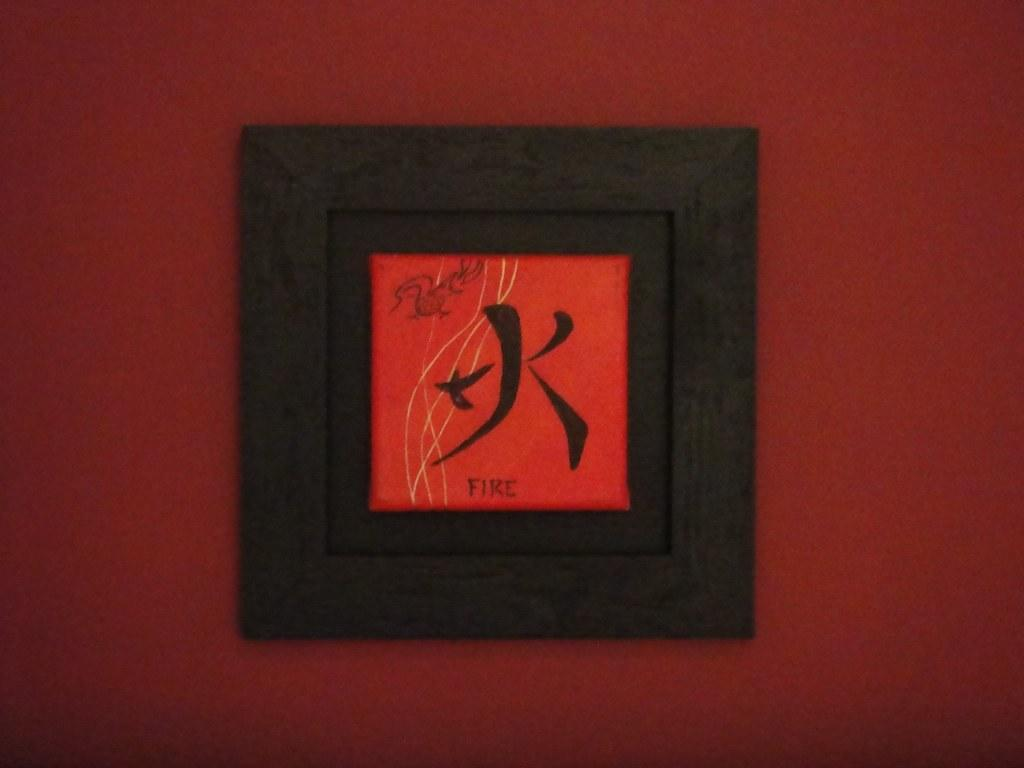<image>
Relay a brief, clear account of the picture shown. A framed out picture of a kanji character representing fire 